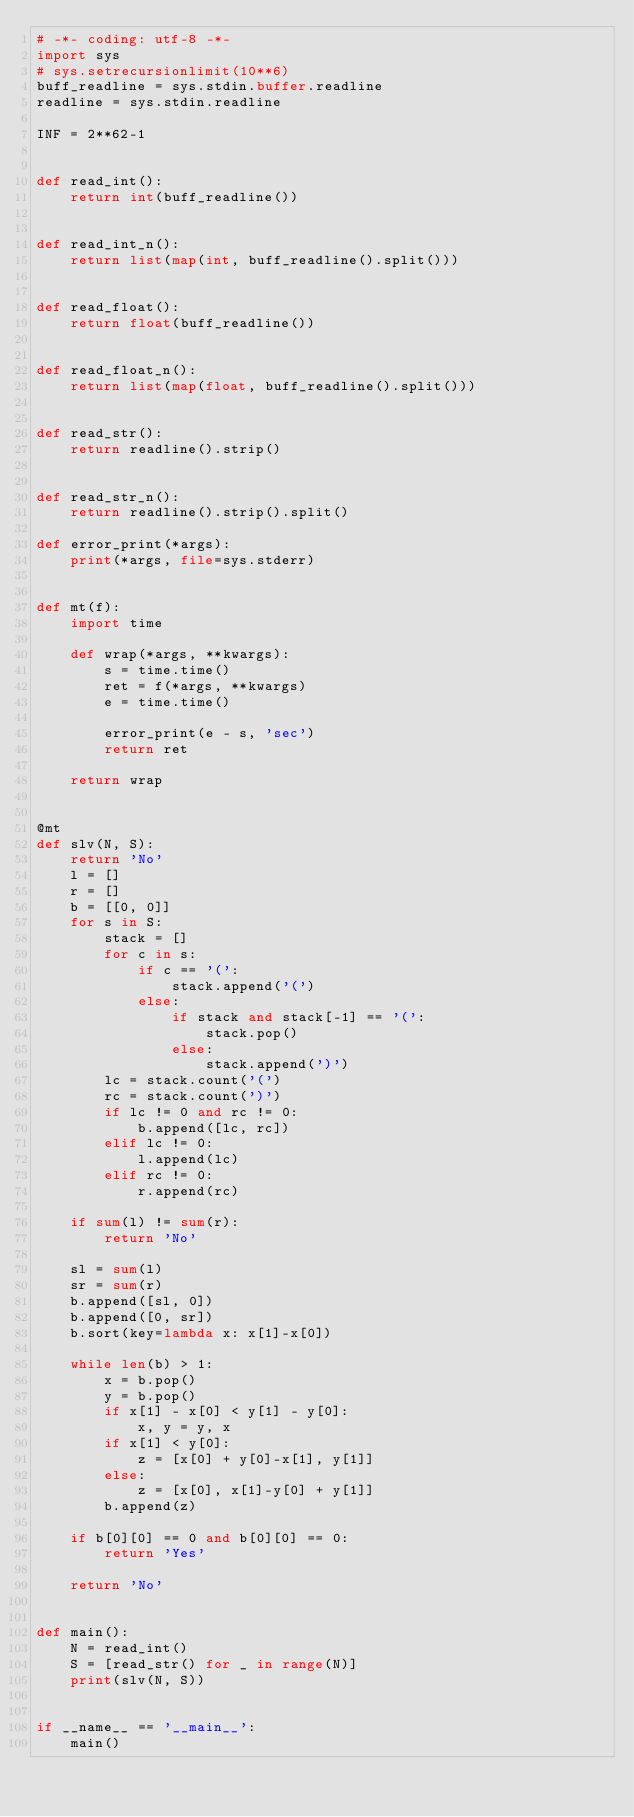Convert code to text. <code><loc_0><loc_0><loc_500><loc_500><_Python_># -*- coding: utf-8 -*-
import sys
# sys.setrecursionlimit(10**6)
buff_readline = sys.stdin.buffer.readline
readline = sys.stdin.readline

INF = 2**62-1


def read_int():
    return int(buff_readline())


def read_int_n():
    return list(map(int, buff_readline().split()))


def read_float():
    return float(buff_readline())


def read_float_n():
    return list(map(float, buff_readline().split()))


def read_str():
    return readline().strip()


def read_str_n():
    return readline().strip().split()

def error_print(*args):
    print(*args, file=sys.stderr)


def mt(f):
    import time

    def wrap(*args, **kwargs):
        s = time.time()
        ret = f(*args, **kwargs)
        e = time.time()

        error_print(e - s, 'sec')
        return ret

    return wrap


@mt
def slv(N, S):
    return 'No'
    l = []
    r = []
    b = [[0, 0]]
    for s in S:
        stack = []
        for c in s:
            if c == '(':
                stack.append('(')
            else:
                if stack and stack[-1] == '(':
                    stack.pop()
                else:
                    stack.append(')')
        lc = stack.count('(')
        rc = stack.count(')')
        if lc != 0 and rc != 0:
            b.append([lc, rc])
        elif lc != 0:
            l.append(lc)
        elif rc != 0:
            r.append(rc)

    if sum(l) != sum(r):
        return 'No'

    sl = sum(l)
    sr = sum(r)
    b.append([sl, 0])
    b.append([0, sr])
    b.sort(key=lambda x: x[1]-x[0])

    while len(b) > 1:
        x = b.pop()
        y = b.pop()
        if x[1] - x[0] < y[1] - y[0]:
            x, y = y, x
        if x[1] < y[0]:
            z = [x[0] + y[0]-x[1], y[1]]
        else:
            z = [x[0], x[1]-y[0] + y[1]]
        b.append(z)

    if b[0][0] == 0 and b[0][0] == 0:
        return 'Yes'

    return 'No'


def main():
    N = read_int()
    S = [read_str() for _ in range(N)]
    print(slv(N, S))


if __name__ == '__main__':
    main()
</code> 